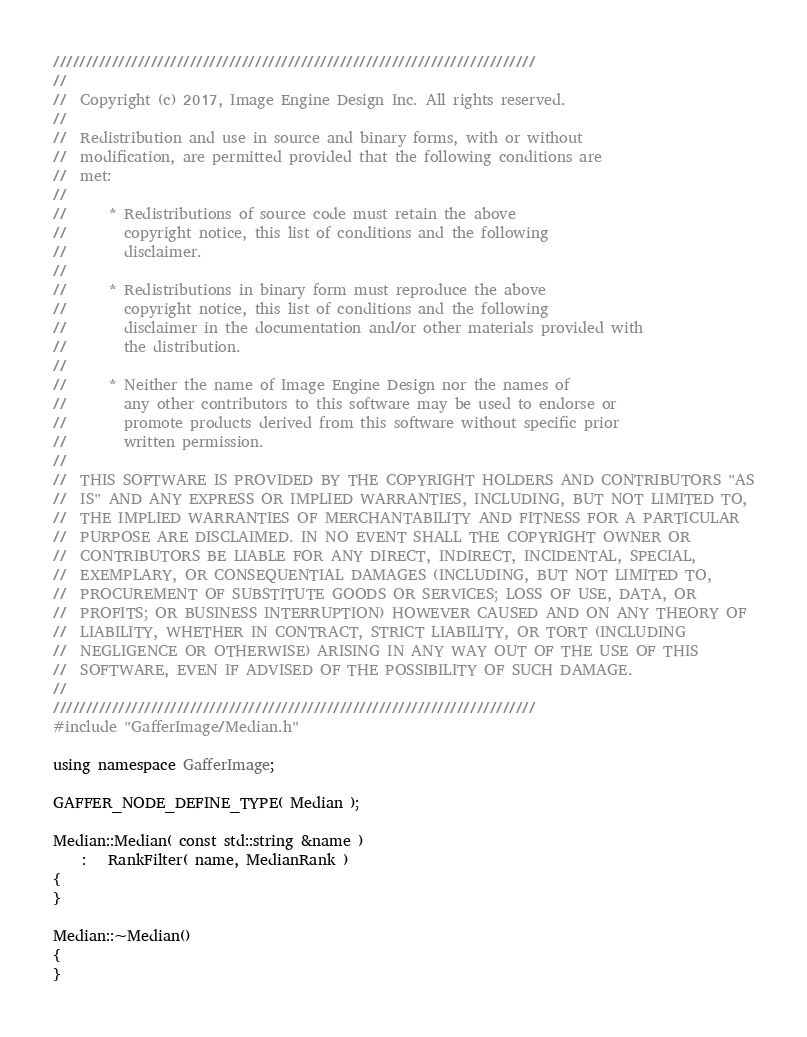<code> <loc_0><loc_0><loc_500><loc_500><_C++_>//////////////////////////////////////////////////////////////////////////
//
//  Copyright (c) 2017, Image Engine Design Inc. All rights reserved.
//
//  Redistribution and use in source and binary forms, with or without
//  modification, are permitted provided that the following conditions are
//  met:
//
//      * Redistributions of source code must retain the above
//        copyright notice, this list of conditions and the following
//        disclaimer.
//
//      * Redistributions in binary form must reproduce the above
//        copyright notice, this list of conditions and the following
//        disclaimer in the documentation and/or other materials provided with
//        the distribution.
//
//      * Neither the name of Image Engine Design nor the names of
//        any other contributors to this software may be used to endorse or
//        promote products derived from this software without specific prior
//        written permission.
//
//  THIS SOFTWARE IS PROVIDED BY THE COPYRIGHT HOLDERS AND CONTRIBUTORS "AS
//  IS" AND ANY EXPRESS OR IMPLIED WARRANTIES, INCLUDING, BUT NOT LIMITED TO,
//  THE IMPLIED WARRANTIES OF MERCHANTABILITY AND FITNESS FOR A PARTICULAR
//  PURPOSE ARE DISCLAIMED. IN NO EVENT SHALL THE COPYRIGHT OWNER OR
//  CONTRIBUTORS BE LIABLE FOR ANY DIRECT, INDIRECT, INCIDENTAL, SPECIAL,
//  EXEMPLARY, OR CONSEQUENTIAL DAMAGES (INCLUDING, BUT NOT LIMITED TO,
//  PROCUREMENT OF SUBSTITUTE GOODS OR SERVICES; LOSS OF USE, DATA, OR
//  PROFITS; OR BUSINESS INTERRUPTION) HOWEVER CAUSED AND ON ANY THEORY OF
//  LIABILITY, WHETHER IN CONTRACT, STRICT LIABILITY, OR TORT (INCLUDING
//  NEGLIGENCE OR OTHERWISE) ARISING IN ANY WAY OUT OF THE USE OF THIS
//  SOFTWARE, EVEN IF ADVISED OF THE POSSIBILITY OF SUCH DAMAGE.
//
//////////////////////////////////////////////////////////////////////////
#include "GafferImage/Median.h"

using namespace GafferImage;

GAFFER_NODE_DEFINE_TYPE( Median );

Median::Median( const std::string &name )
	:   RankFilter( name, MedianRank )
{
}

Median::~Median()
{
}
</code> 